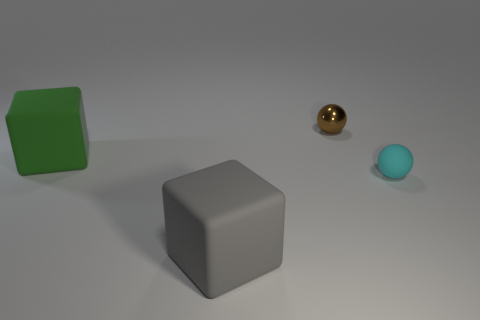Do the matte cube that is to the left of the gray rubber object and the brown object have the same size?
Make the answer very short. No. Is there a object that has the same color as the tiny rubber sphere?
Your answer should be compact. No. Are there any gray rubber objects that are behind the object on the right side of the tiny brown shiny sphere?
Offer a terse response. No. Is there a large gray thing that has the same material as the tiny cyan sphere?
Provide a succinct answer. Yes. What material is the cube behind the large thing on the right side of the large green cube?
Keep it short and to the point. Rubber. The thing that is in front of the green object and to the right of the big gray block is made of what material?
Make the answer very short. Rubber. Is the number of tiny cyan balls in front of the cyan matte thing the same as the number of shiny things?
Ensure brevity in your answer.  No. How many other objects are the same shape as the shiny object?
Give a very brief answer. 1. There is a ball to the left of the small cyan thing that is in front of the sphere that is left of the small cyan rubber thing; how big is it?
Provide a succinct answer. Small. Does the block on the right side of the big green matte block have the same material as the small brown object?
Provide a short and direct response. No. 